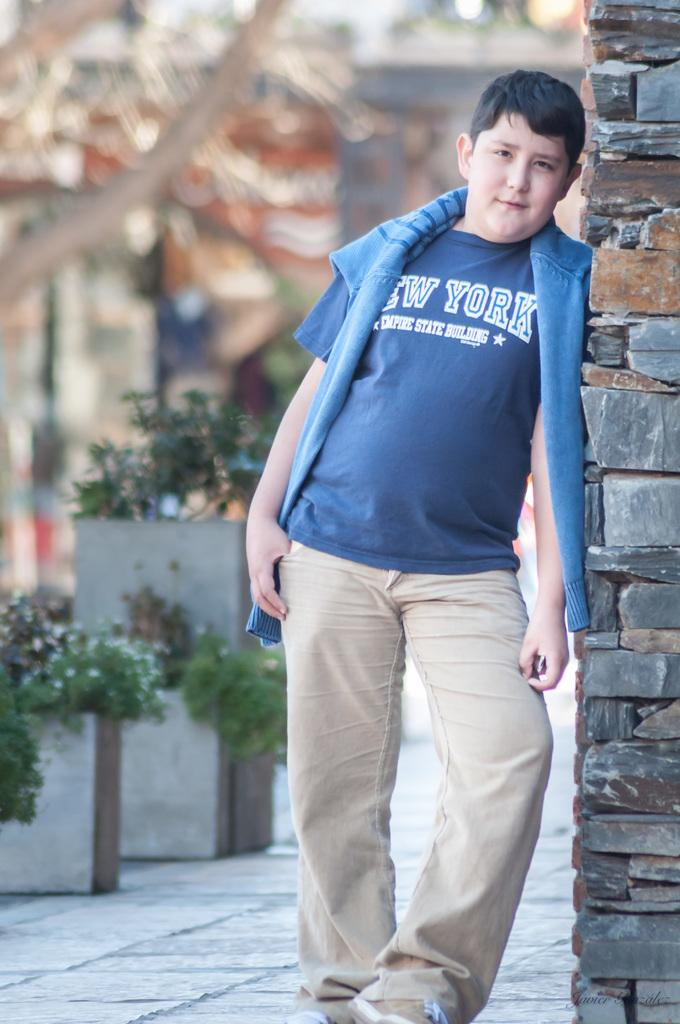What is the main subject of the image? There is a boy standing in the image. What else can be seen in the image besides the boy? There are plants in pots and buildings visible in the image. What type of vegetation is present in the image? There are plants in pots and a tree in the background of the image. Can you hear the boy crying in the image? There is no sound in the image, so it is not possible to determine if the boy is crying or not. 